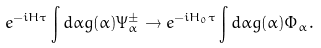<formula> <loc_0><loc_0><loc_500><loc_500>e ^ { - i H \tau } \int d \alpha g ( \alpha ) \Psi _ { \alpha } ^ { \pm } \rightarrow e ^ { - i H _ { 0 } \tau } \int d \alpha g ( \alpha ) \Phi _ { \alpha } .</formula> 